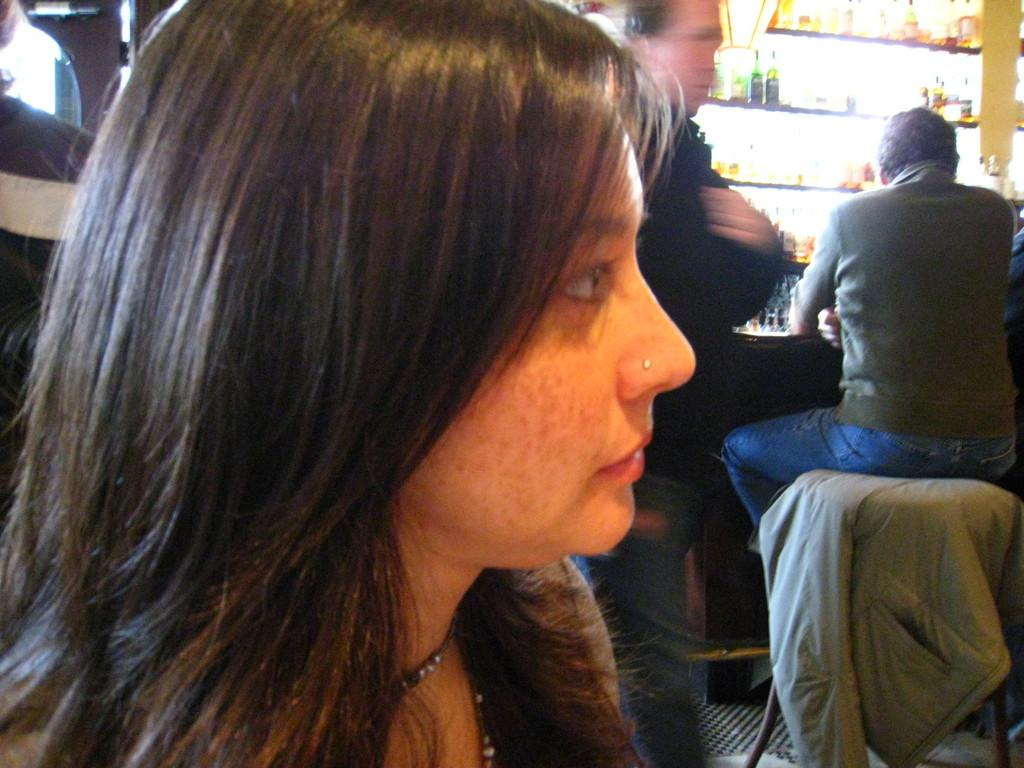Who is the main subject in the front of the image? There is a woman in the front of the image. What can be seen in the background of the image? There are men in the background of the image. Where are the bottles located in the image? The bottles are on the right side of the image. What is the price of the error in the image? There is no error present in the image, and therefore no price can be associated with it. 